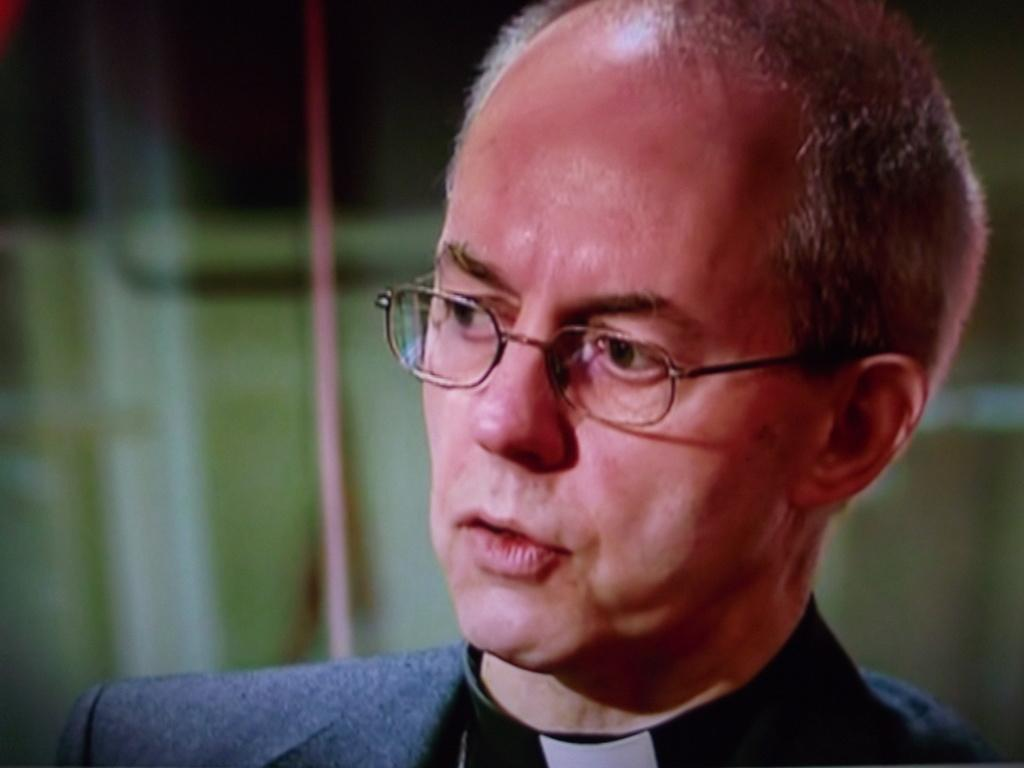Who is present in the image? There is a man in the picture. Can you describe the man's hair in the image? The man has a bald head with some hair. What is the man wearing in the image? The man is wearing a black blazer. What type of fan is visible in the image? There is no fan present in the image. Is there any shade provided by the man in the image? The man is not providing any shade in the image. 